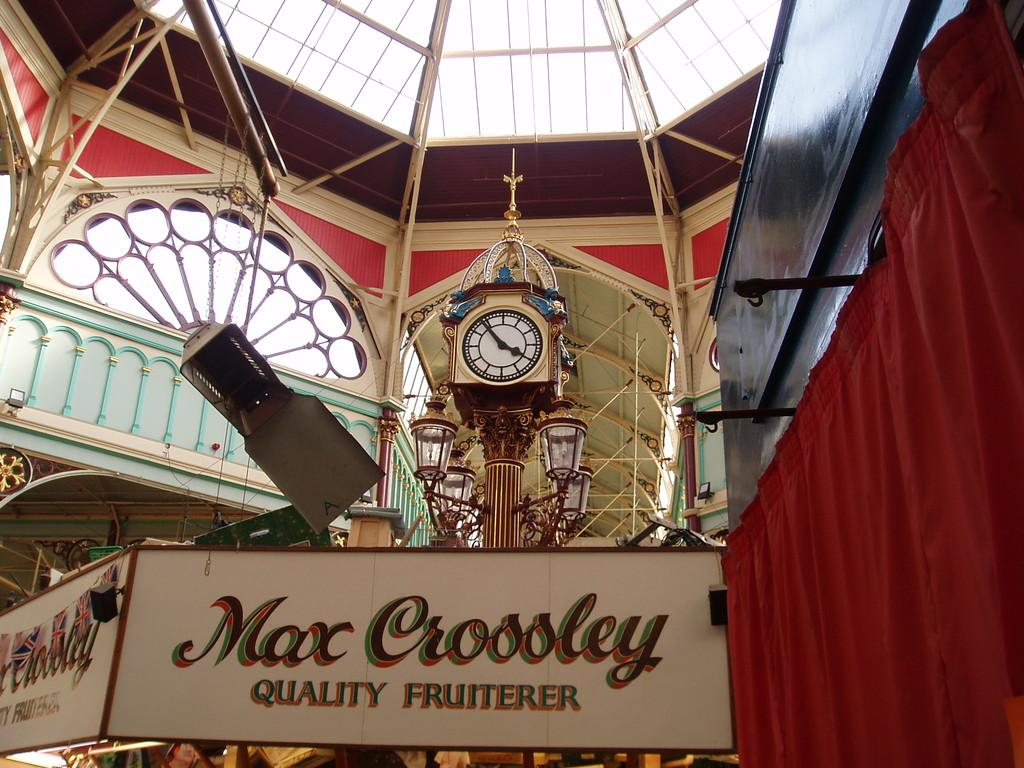<image>
Relay a brief, clear account of the picture shown. The inside of a building with a Max Croosley sign in front of a clock tower. 